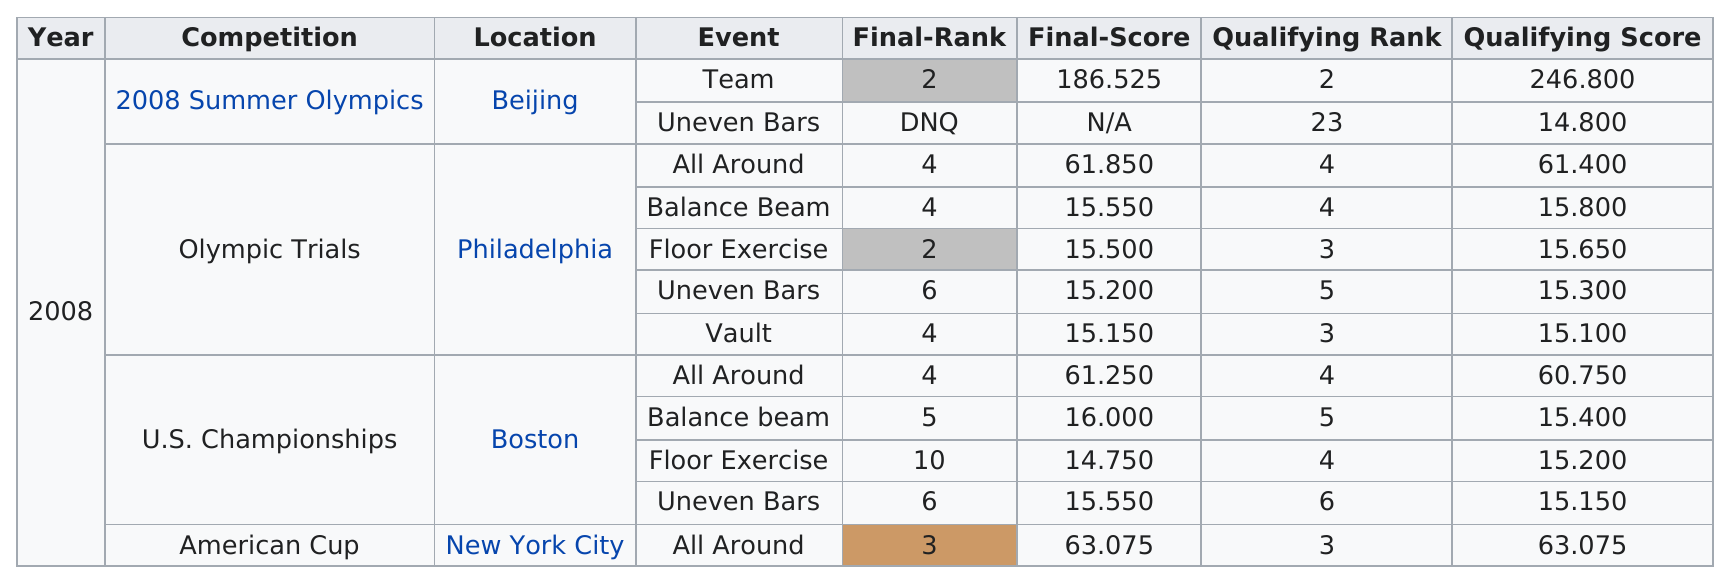Specify some key components in this picture. There have been a total of 5 events held in Philadelphia. There were 8 qualifying scores that were above 15.2. A total of 10 consecutive events took place in Beijing, starting from event 2 and ending with event 10. In the aftermath of the 2008 Olympic Trials, this competitor proceeded to the U.S. Championships, which marked their next competition. In 2008, this competitor participated in a team event that was the only competition they attended that year. That competition was the 2008 Summer Olympics. 